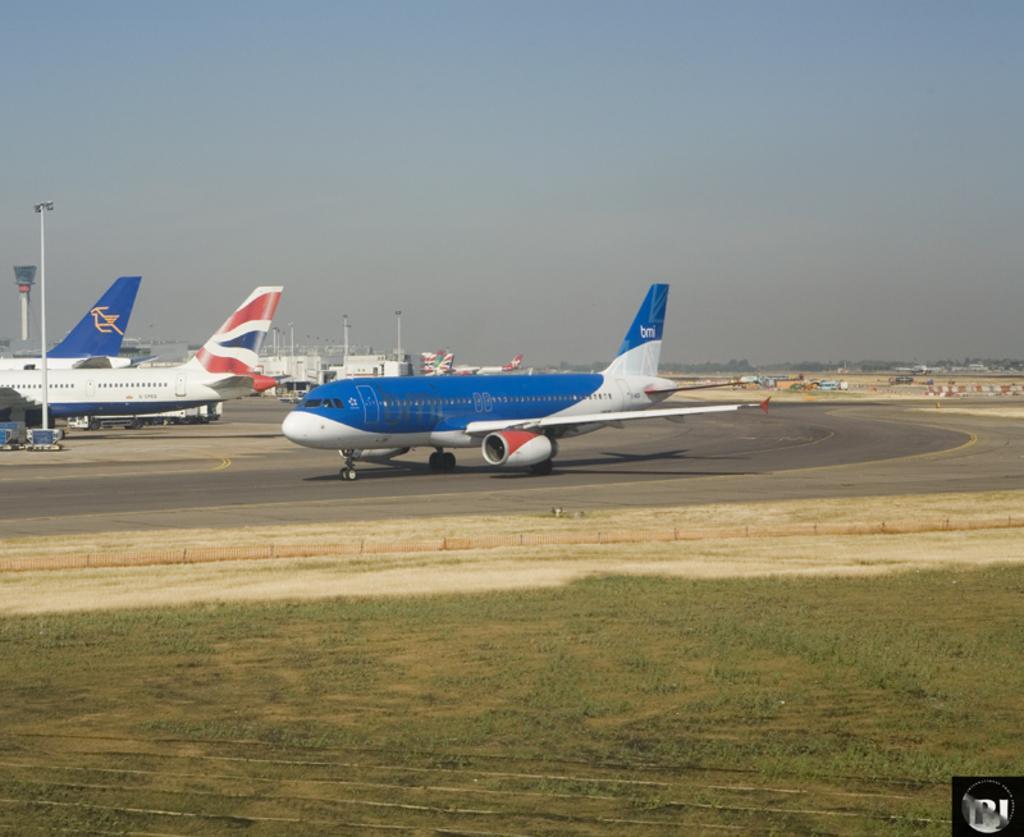Please provide a concise description of this image. In this image, we can see aeroplanes on the road and there are sheds. At the bottom, there is ground. 